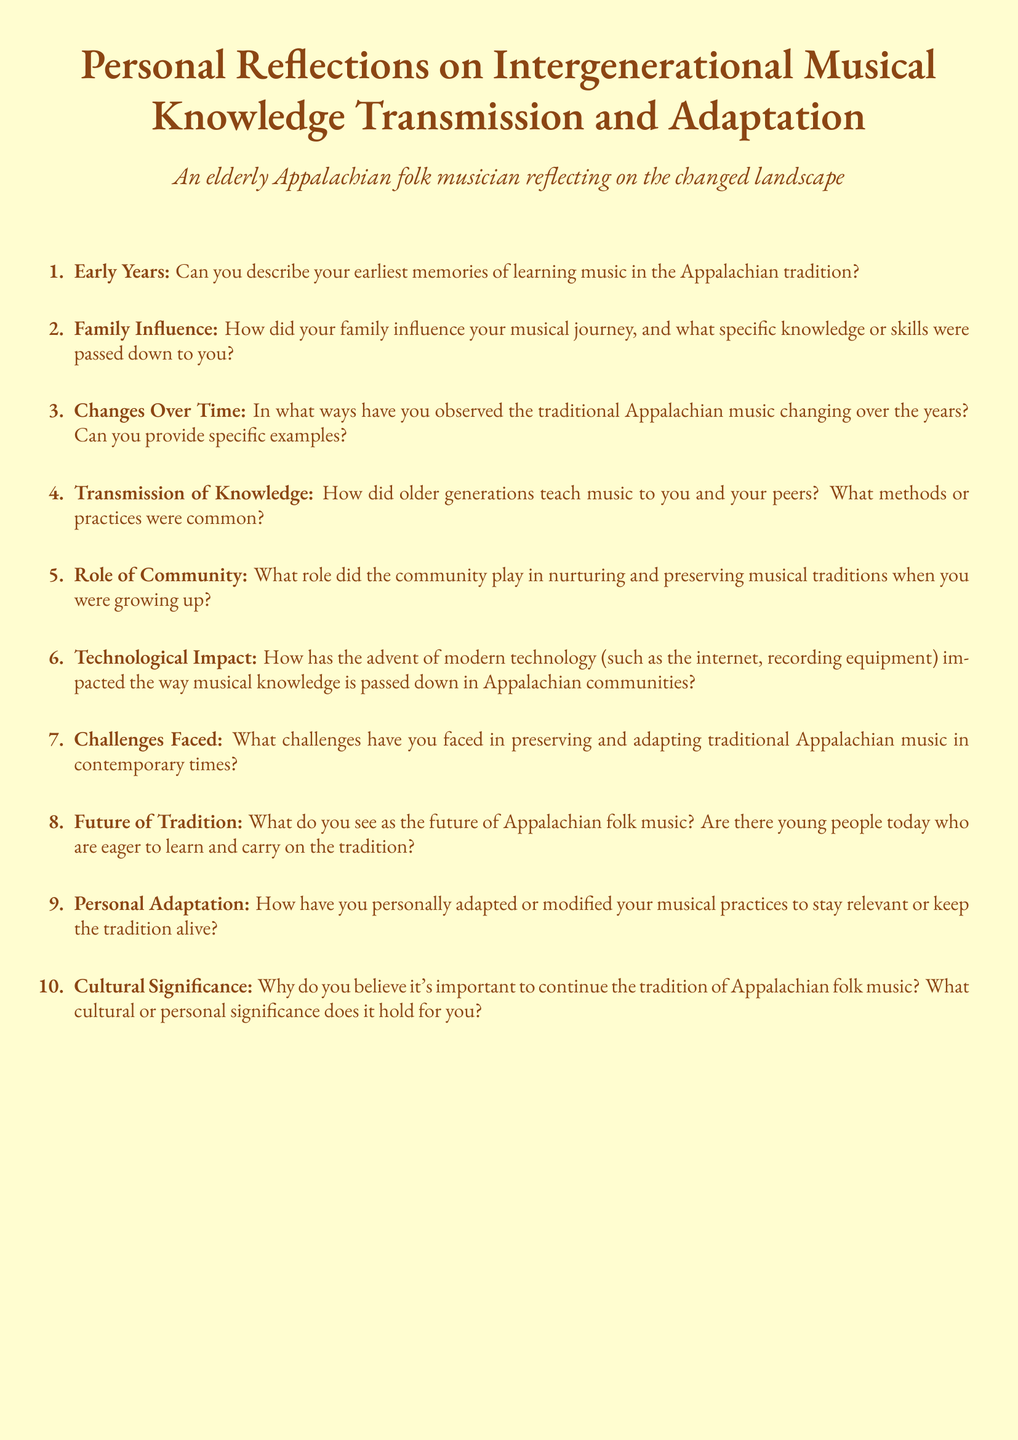What are the document's main themes? The document focuses on personal reflections regarding the transmission and adaptation of musical knowledge within the Appalachian folk tradition.
Answer: Musical knowledge transmission and adaptation How many main sections does the document contain? There are ten distinct topics covered in the questionnaire.
Answer: Ten What term describes the role of the community in the document? The document refers to the role that the community played in nurturing and preserving musical traditions, highlighting its importance.
Answer: Community What type of musician does the document reflect on? The questionnaire is aimed at gathering insights from an elderly musician reflecting on their experiences.
Answer: Elderly Appalachian folk musician What is one method of knowledge transmission mentioned? The document suggests that older generations had specific methods/practices for teaching music.
Answer: Methods/practices Which technology's impact is discussed in the document? The document mentions modern technology, including the internet and recording equipment, and its effect on musical knowledge transmission.
Answer: Modern technology What is the future outlook of Appalachian folk music according to the document? The document prompts the respondent to express their views on the future of Appalachian folk music and the eagerness of youth to learn it.
Answer: Future of Appalachian folk music What kind of challenges does the document mention? The questionnaire asks about the challenges faced in preserving and adapting traditional Appalachian music.
Answer: Challenges in preservation and adaptation Which personal aspect is covered in the document? The questionnaire includes a section on how the respondent has personally adapted their musical practices over time.
Answer: Personal adaptation What cultural significance does Appalachian folk music hold? The document inquires about the cultural or personal significance of continuing the tradition of Appalachian folk music.
Answer: Cultural significance 